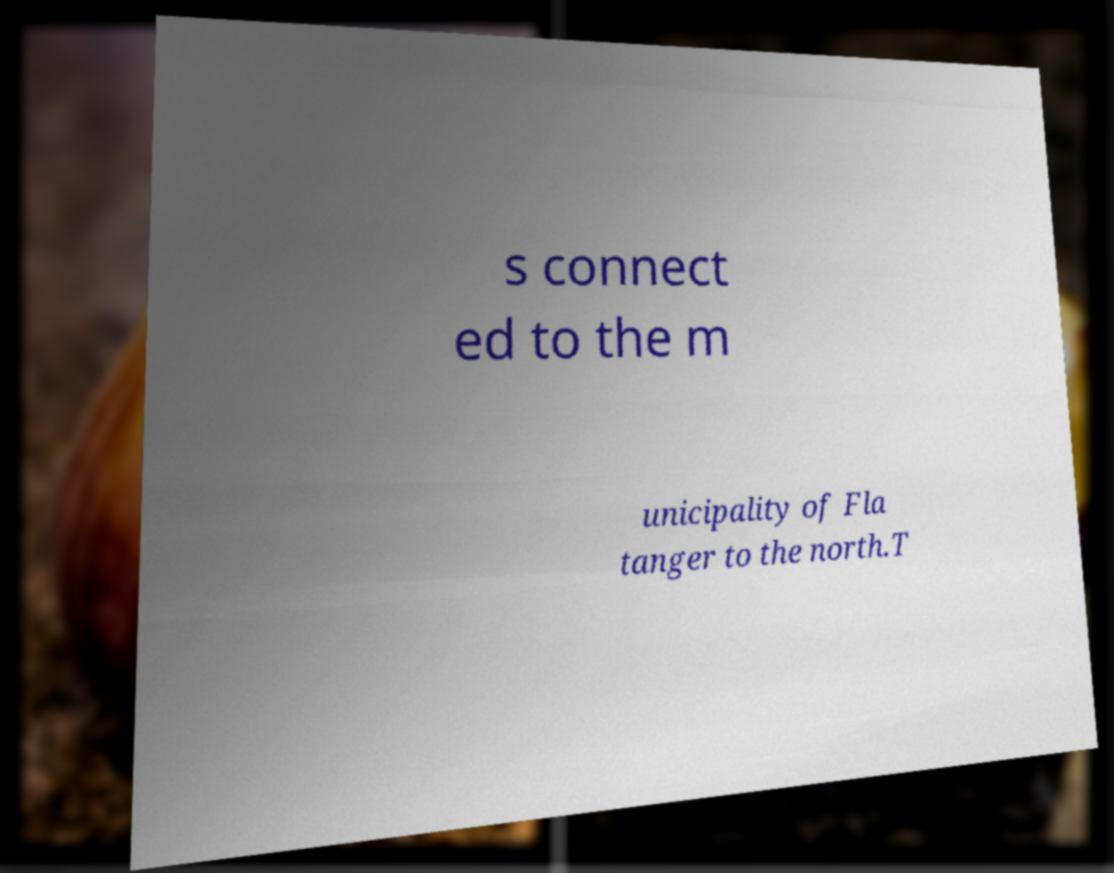Can you accurately transcribe the text from the provided image for me? s connect ed to the m unicipality of Fla tanger to the north.T 